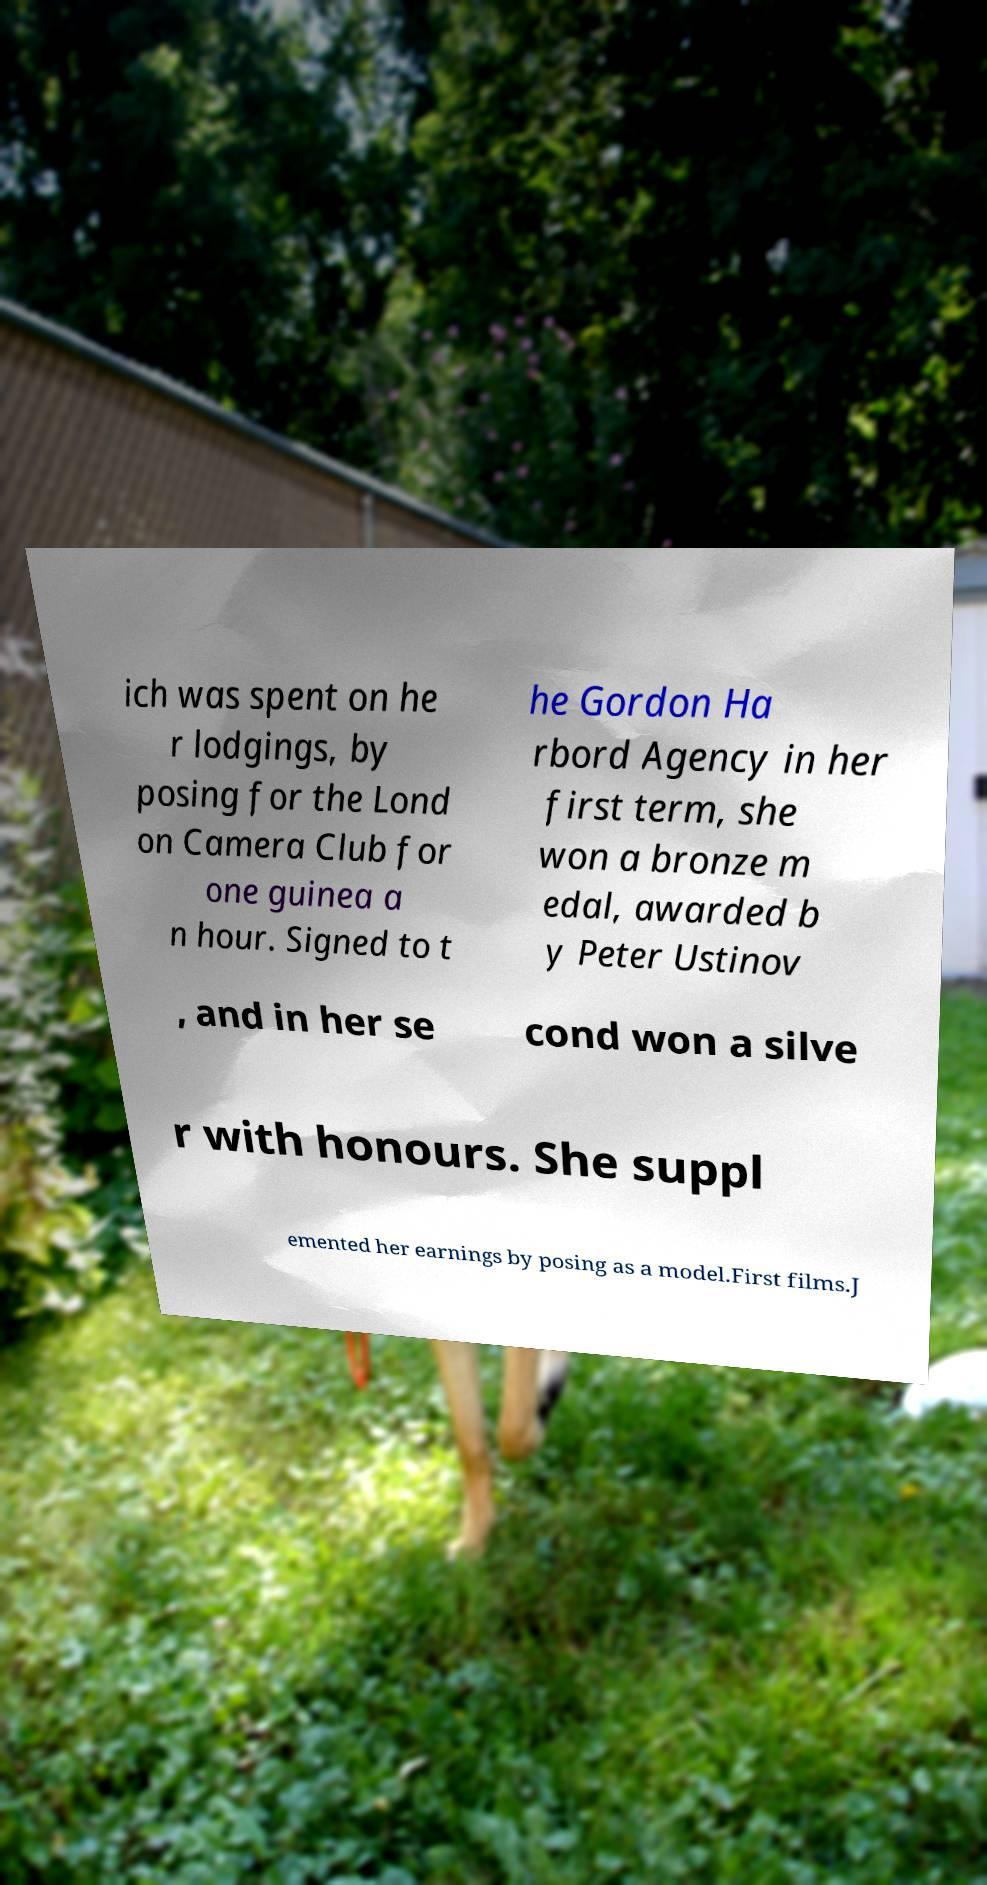Could you assist in decoding the text presented in this image and type it out clearly? ich was spent on he r lodgings, by posing for the Lond on Camera Club for one guinea a n hour. Signed to t he Gordon Ha rbord Agency in her first term, she won a bronze m edal, awarded b y Peter Ustinov , and in her se cond won a silve r with honours. She suppl emented her earnings by posing as a model.First films.J 